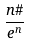<formula> <loc_0><loc_0><loc_500><loc_500>\frac { n \# } { e ^ { n } }</formula> 